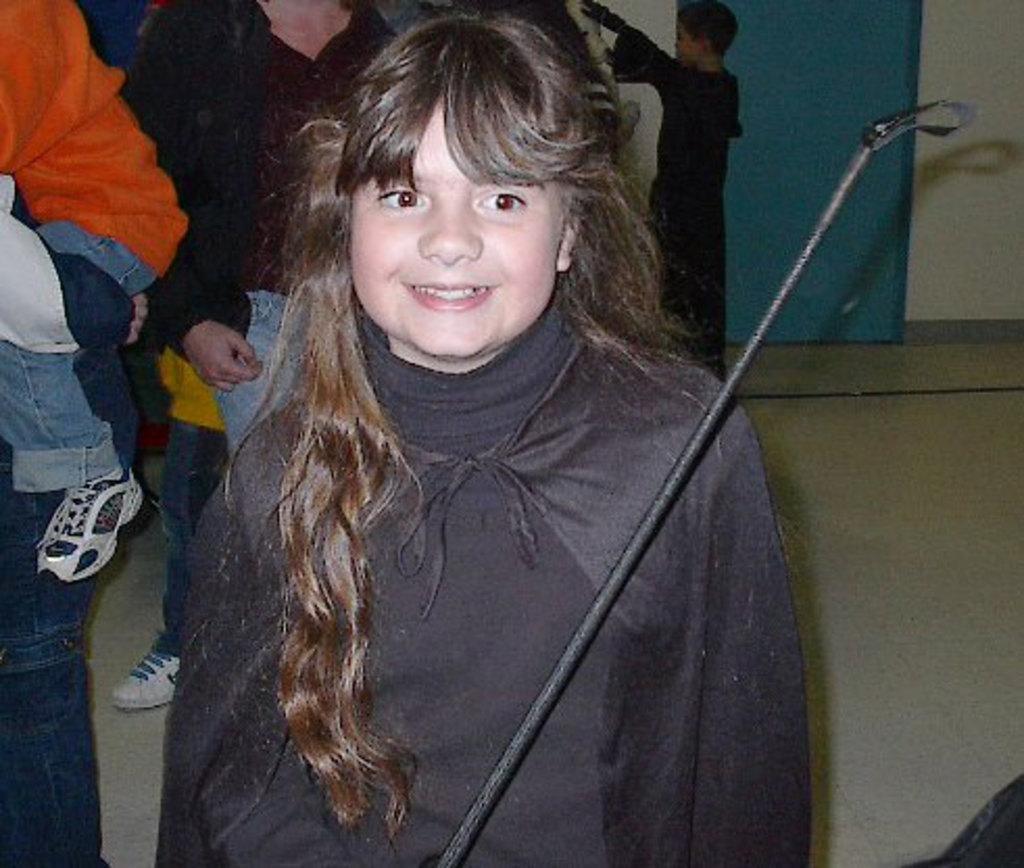How would you summarize this image in a sentence or two? There is a girl wearing a black color dress. In front of her there is a black color rod. In the back there are many people. 